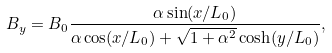Convert formula to latex. <formula><loc_0><loc_0><loc_500><loc_500>B _ { y } = B _ { 0 } \frac { \alpha \sin ( x / L _ { 0 } ) } { \alpha \cos ( x / L _ { 0 } ) + \sqrt { 1 + \alpha ^ { 2 } } \cosh ( y / L _ { 0 } ) } ,</formula> 